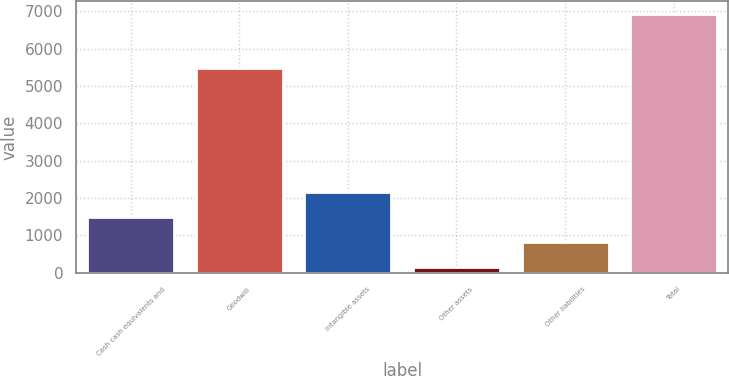<chart> <loc_0><loc_0><loc_500><loc_500><bar_chart><fcel>Cash cash equivalents and<fcel>Goodwill<fcel>Intangible assets<fcel>Other assets<fcel>Other liabilities<fcel>Total<nl><fcel>1499.2<fcel>5497<fcel>2177.3<fcel>143<fcel>821.1<fcel>6924<nl></chart> 